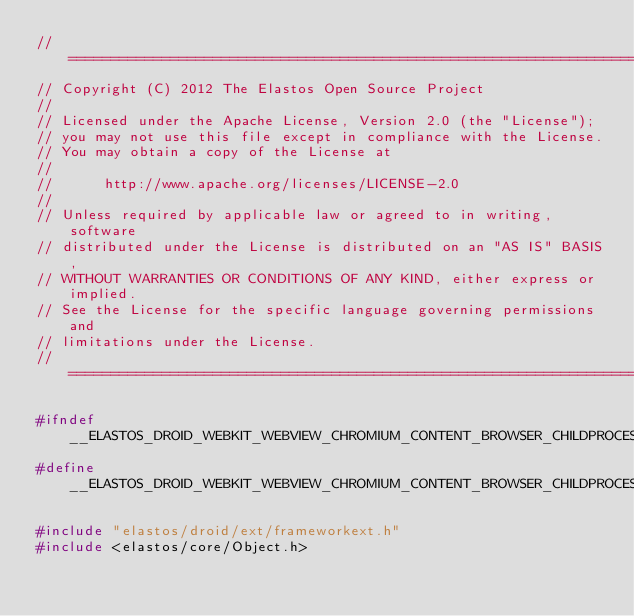<code> <loc_0><loc_0><loc_500><loc_500><_C_>//=========================================================================
// Copyright (C) 2012 The Elastos Open Source Project
//
// Licensed under the Apache License, Version 2.0 (the "License");
// you may not use this file except in compliance with the License.
// You may obtain a copy of the License at
//
//      http://www.apache.org/licenses/LICENSE-2.0
//
// Unless required by applicable law or agreed to in writing, software
// distributed under the License is distributed on an "AS IS" BASIS,
// WITHOUT WARRANTIES OR CONDITIONS OF ANY KIND, either express or implied.
// See the License for the specific language governing permissions and
// limitations under the License.
//=========================================================================

#ifndef __ELASTOS_DROID_WEBKIT_WEBVIEW_CHROMIUM_CONTENT_BROWSER_CHILDPROCESSCONNECTION_H__
#define __ELASTOS_DROID_WEBKIT_WEBVIEW_CHROMIUM_CONTENT_BROWSER_CHILDPROCESSCONNECTION_H__

#include "elastos/droid/ext/frameworkext.h"
#include <elastos/core/Object.h></code> 